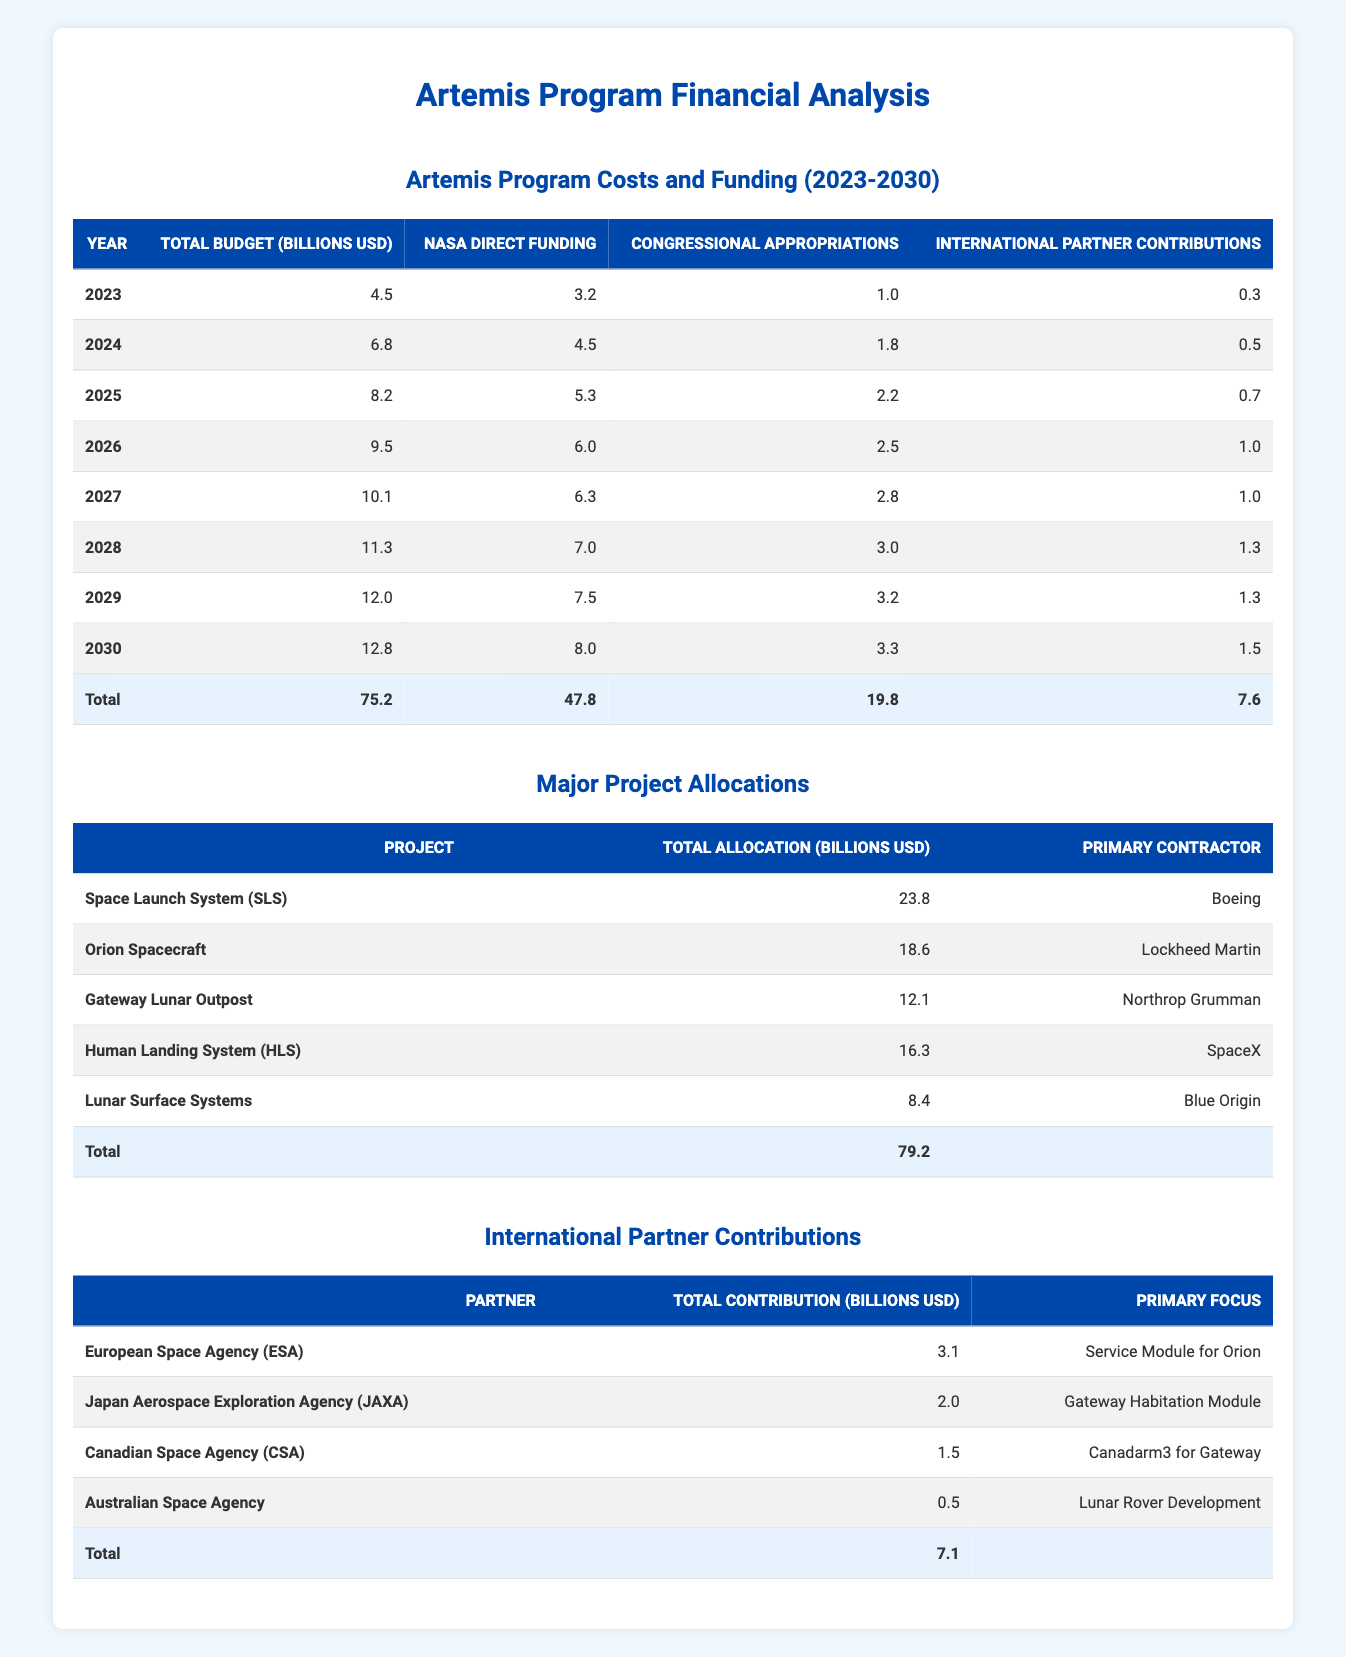What is the total budget for the Artemis program in 2025? In the table under the "Artemis Program Costs and Funding (2023-2030)" section, I look at the entry for the year 2025. The value listed for "Total Budget (Billions USD)" is 8.2.
Answer: 8.2 billion USD How much total funding is anticipated from international partners in 2027? In the "Artemis Program Costs and Funding (2023-2030)" table, for the year 2027, the entry under "International Partner Contributions" shows a value of 1.0.
Answer: 1.0 billion USD What was the increase in total budget from 2023 to 2024? To find this, I subtract the total budget for 2023 (4.5) from the total budget for 2024 (6.8). The difference is 6.8 - 4.5 = 2.3.
Answer: 2.3 billion USD What is the average annual funding from NASA for the years 2023 to 2030? I sum all the NASA Direct Funding amounts from 2023 to 2030: 3.2 + 4.5 + 5.3 + 6.0 + 6.3 + 7.0 + 7.5 + 8.0 = 47.8. There are 8 years, so the average is 47.8 / 8 = 5.975.
Answer: 5.975 billion USD Is the total allocation for the Human Landing System greater than the total for the Gateway Lunar Outpost? The total allocation for the Human Landing System (HLS) is 16.3 and for the Gateway Lunar Outpost it is 12.1. Since 16.3 > 12.1, the fact is true.
Answer: Yes Which project's total allocation is the highest, and how much is it? In the "Major Project Allocations" table, I compare the "Total Allocation" values. The Space Launch System (SLS) has an allocation of 23.8, which is higher than any other project.
Answer: Space Launch System (SLS), 23.8 billion USD What is the total contribution from the Canadian Space Agency (CSA)? Referring to the "International Partner Contributions" table, I see that the total contribution from the Canadian Space Agency is listed as 1.5.
Answer: 1.5 billion USD What is the difference in NASA direct funding between 2029 and 2030? I check the entries for NASA Direct Funding. For 2029, it is 7.5, and for 2030, it is 8.0. I calculate the difference as 8.0 - 7.5 = 0.5.
Answer: 0.5 billion USD What percentage of the total budget in 2026 comes from congressional appropriations? The total budget for 2026 is 9.5, and congressional appropriations are 2.5. To find the percentage, I calculate (2.5 / 9.5) * 100 = 26.32%.
Answer: 26.32% 